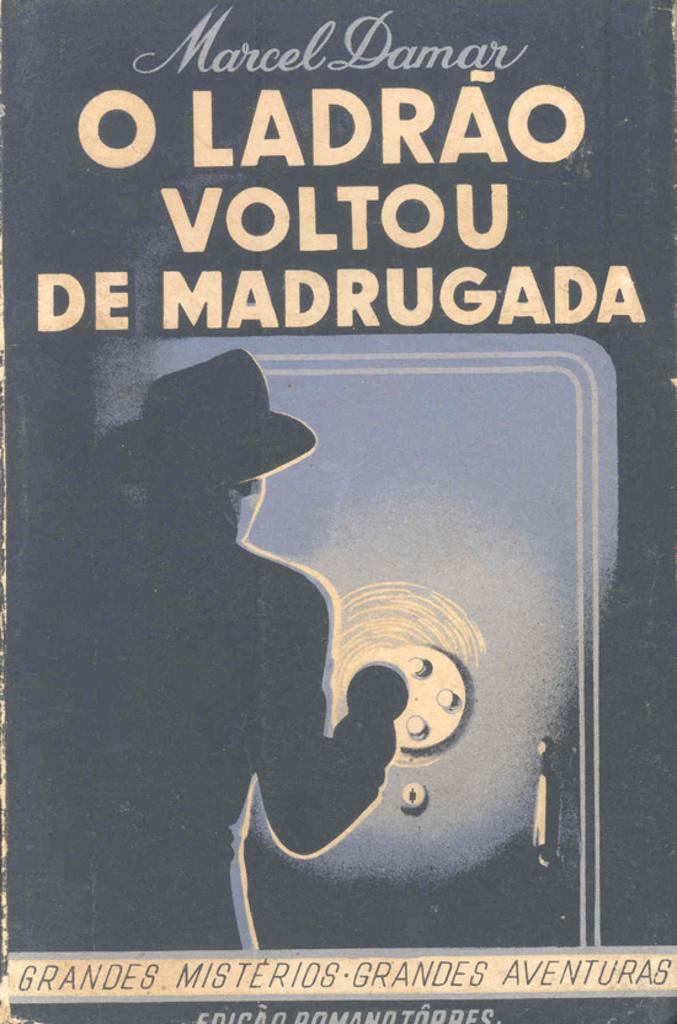Provide a one-sentence caption for the provided image. An old poster of a guy shining a light on a large safe with the words O Ladrao Voltou De Madrugada on it. 